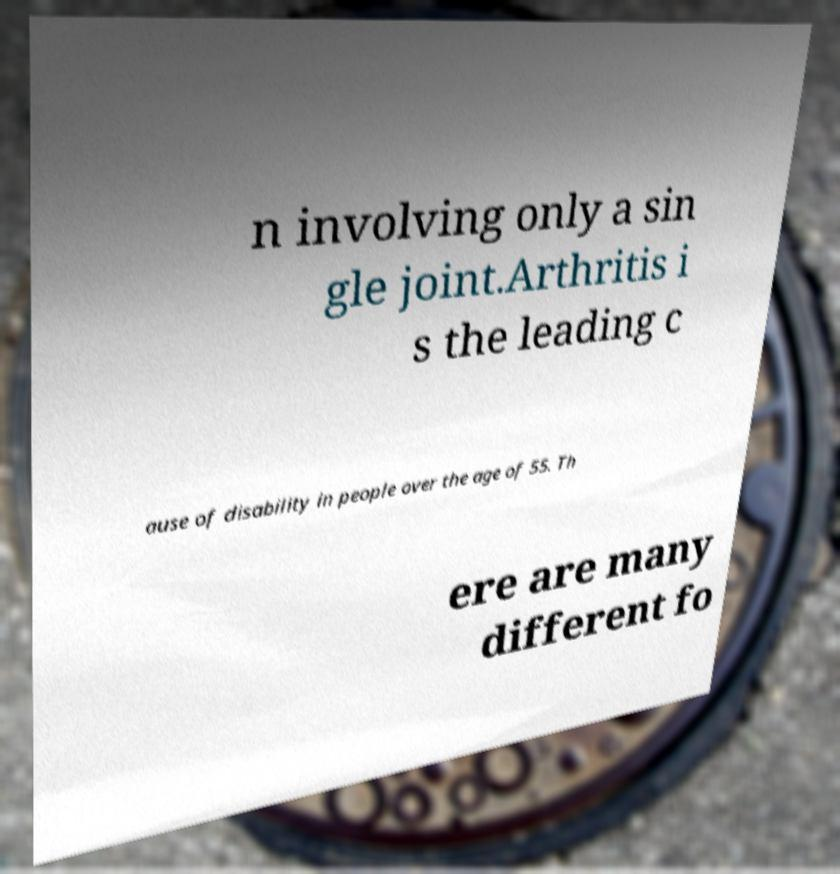Could you assist in decoding the text presented in this image and type it out clearly? n involving only a sin gle joint.Arthritis i s the leading c ause of disability in people over the age of 55. Th ere are many different fo 